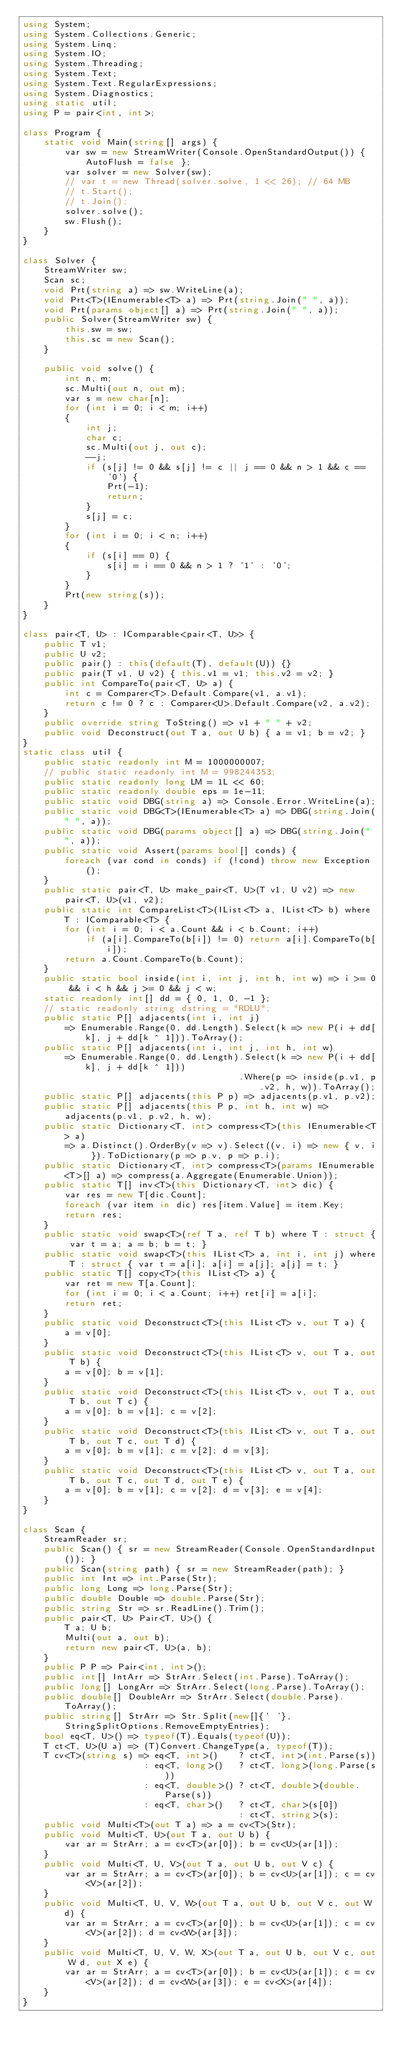<code> <loc_0><loc_0><loc_500><loc_500><_C#_>using System;
using System.Collections.Generic;
using System.Linq;
using System.IO;
using System.Threading;
using System.Text;
using System.Text.RegularExpressions;
using System.Diagnostics;
using static util;
using P = pair<int, int>;

class Program {
    static void Main(string[] args) {
        var sw = new StreamWriter(Console.OpenStandardOutput()) { AutoFlush = false };
        var solver = new Solver(sw);
        // var t = new Thread(solver.solve, 1 << 26); // 64 MB
        // t.Start();
        // t.Join();
        solver.solve();
        sw.Flush();
    }
}

class Solver {
    StreamWriter sw;
    Scan sc;
    void Prt(string a) => sw.WriteLine(a);
    void Prt<T>(IEnumerable<T> a) => Prt(string.Join(" ", a));
    void Prt(params object[] a) => Prt(string.Join(" ", a));
    public Solver(StreamWriter sw) {
        this.sw = sw;
        this.sc = new Scan();
    }

    public void solve() {
        int n, m;
        sc.Multi(out n, out m);
        var s = new char[n];
        for (int i = 0; i < m; i++)
        {
            int j;
            char c;
            sc.Multi(out j, out c);
            --j;
            if (s[j] != 0 && s[j] != c || j == 0 && n > 1 && c == '0') {
                Prt(-1);
                return;
            }
            s[j] = c;
        }
        for (int i = 0; i < n; i++)
        {
            if (s[i] == 0) {
                s[i] = i == 0 && n > 1 ? '1' : '0';
            }
        }
        Prt(new string(s));
    }
}

class pair<T, U> : IComparable<pair<T, U>> {
    public T v1;
    public U v2;
    public pair() : this(default(T), default(U)) {}
    public pair(T v1, U v2) { this.v1 = v1; this.v2 = v2; }
    public int CompareTo(pair<T, U> a) {
        int c = Comparer<T>.Default.Compare(v1, a.v1);
        return c != 0 ? c : Comparer<U>.Default.Compare(v2, a.v2);
    }
    public override string ToString() => v1 + " " + v2;
    public void Deconstruct(out T a, out U b) { a = v1; b = v2; }
}
static class util {
    public static readonly int M = 1000000007;
    // public static readonly int M = 998244353;
    public static readonly long LM = 1L << 60;
    public static readonly double eps = 1e-11;
    public static void DBG(string a) => Console.Error.WriteLine(a);
    public static void DBG<T>(IEnumerable<T> a) => DBG(string.Join(" ", a));
    public static void DBG(params object[] a) => DBG(string.Join(" ", a));
    public static void Assert(params bool[] conds) {
        foreach (var cond in conds) if (!cond) throw new Exception();
    }
    public static pair<T, U> make_pair<T, U>(T v1, U v2) => new pair<T, U>(v1, v2);
    public static int CompareList<T>(IList<T> a, IList<T> b) where T : IComparable<T> {
        for (int i = 0; i < a.Count && i < b.Count; i++)
            if (a[i].CompareTo(b[i]) != 0) return a[i].CompareTo(b[i]);
        return a.Count.CompareTo(b.Count);
    }
    public static bool inside(int i, int j, int h, int w) => i >= 0 && i < h && j >= 0 && j < w;
    static readonly int[] dd = { 0, 1, 0, -1 };
    // static readonly string dstring = "RDLU";
    public static P[] adjacents(int i, int j)
        => Enumerable.Range(0, dd.Length).Select(k => new P(i + dd[k], j + dd[k ^ 1])).ToArray();
    public static P[] adjacents(int i, int j, int h, int w)
        => Enumerable.Range(0, dd.Length).Select(k => new P(i + dd[k], j + dd[k ^ 1]))
                                         .Where(p => inside(p.v1, p.v2, h, w)).ToArray();
    public static P[] adjacents(this P p) => adjacents(p.v1, p.v2);
    public static P[] adjacents(this P p, int h, int w) => adjacents(p.v1, p.v2, h, w);
    public static Dictionary<T, int> compress<T>(this IEnumerable<T> a)
        => a.Distinct().OrderBy(v => v).Select((v, i) => new { v, i }).ToDictionary(p => p.v, p => p.i);
    public static Dictionary<T, int> compress<T>(params IEnumerable<T>[] a) => compress(a.Aggregate(Enumerable.Union));
    public static T[] inv<T>(this Dictionary<T, int> dic) {
        var res = new T[dic.Count];
        foreach (var item in dic) res[item.Value] = item.Key;
        return res;
    }
    public static void swap<T>(ref T a, ref T b) where T : struct { var t = a; a = b; b = t; }
    public static void swap<T>(this IList<T> a, int i, int j) where T : struct { var t = a[i]; a[i] = a[j]; a[j] = t; }
    public static T[] copy<T>(this IList<T> a) {
        var ret = new T[a.Count];
        for (int i = 0; i < a.Count; i++) ret[i] = a[i];
        return ret;
    }
    public static void Deconstruct<T>(this IList<T> v, out T a) {
        a = v[0];
    }
    public static void Deconstruct<T>(this IList<T> v, out T a, out T b) {
        a = v[0]; b = v[1];
    }
    public static void Deconstruct<T>(this IList<T> v, out T a, out T b, out T c) {
        a = v[0]; b = v[1]; c = v[2];
    }
    public static void Deconstruct<T>(this IList<T> v, out T a, out T b, out T c, out T d) {
        a = v[0]; b = v[1]; c = v[2]; d = v[3];
    }
    public static void Deconstruct<T>(this IList<T> v, out T a, out T b, out T c, out T d, out T e) {
        a = v[0]; b = v[1]; c = v[2]; d = v[3]; e = v[4];
    }
}

class Scan {
    StreamReader sr;
    public Scan() { sr = new StreamReader(Console.OpenStandardInput()); }
    public Scan(string path) { sr = new StreamReader(path); }
    public int Int => int.Parse(Str);
    public long Long => long.Parse(Str);
    public double Double => double.Parse(Str);
    public string Str => sr.ReadLine().Trim();
    public pair<T, U> Pair<T, U>() {
        T a; U b;
        Multi(out a, out b);
        return new pair<T, U>(a, b);
    }
    public P P => Pair<int, int>();
    public int[] IntArr => StrArr.Select(int.Parse).ToArray();
    public long[] LongArr => StrArr.Select(long.Parse).ToArray();
    public double[] DoubleArr => StrArr.Select(double.Parse).ToArray();
    public string[] StrArr => Str.Split(new[]{' '}, StringSplitOptions.RemoveEmptyEntries);
    bool eq<T, U>() => typeof(T).Equals(typeof(U));
    T ct<T, U>(U a) => (T)Convert.ChangeType(a, typeof(T));
    T cv<T>(string s) => eq<T, int>()    ? ct<T, int>(int.Parse(s))
                       : eq<T, long>()   ? ct<T, long>(long.Parse(s))
                       : eq<T, double>() ? ct<T, double>(double.Parse(s))
                       : eq<T, char>()   ? ct<T, char>(s[0])
                                         : ct<T, string>(s);
    public void Multi<T>(out T a) => a = cv<T>(Str);
    public void Multi<T, U>(out T a, out U b) {
        var ar = StrArr; a = cv<T>(ar[0]); b = cv<U>(ar[1]);
    }
    public void Multi<T, U, V>(out T a, out U b, out V c) {
        var ar = StrArr; a = cv<T>(ar[0]); b = cv<U>(ar[1]); c = cv<V>(ar[2]);
    }
    public void Multi<T, U, V, W>(out T a, out U b, out V c, out W d) {
        var ar = StrArr; a = cv<T>(ar[0]); b = cv<U>(ar[1]); c = cv<V>(ar[2]); d = cv<W>(ar[3]);
    }
    public void Multi<T, U, V, W, X>(out T a, out U b, out V c, out W d, out X e) {
        var ar = StrArr; a = cv<T>(ar[0]); b = cv<U>(ar[1]); c = cv<V>(ar[2]); d = cv<W>(ar[3]); e = cv<X>(ar[4]);
    }
}
</code> 